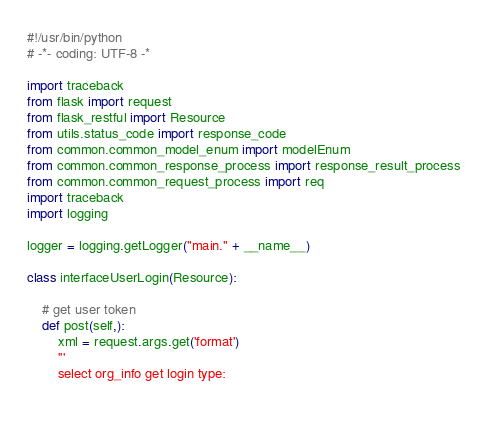Convert code to text. <code><loc_0><loc_0><loc_500><loc_500><_Python_>#!/usr/bin/python
# -*- coding: UTF-8 -*

import traceback
from flask import request
from flask_restful import Resource
from utils.status_code import response_code
from common.common_model_enum import modelEnum
from common.common_response_process import response_result_process
from common.common_request_process import req
import traceback
import logging

logger = logging.getLogger("main." + __name__)

class interfaceUserLogin(Resource):

    # get user token
    def post(self,):
        xml = request.args.get('format')
        '''
        select org_info get login type:
        </code> 